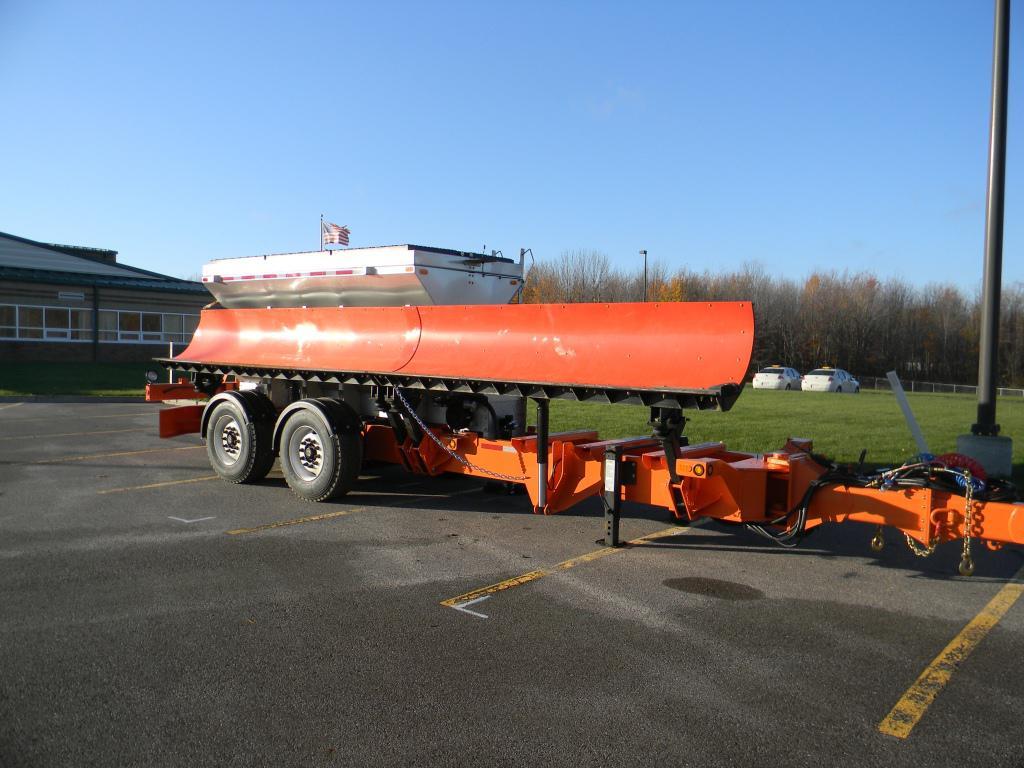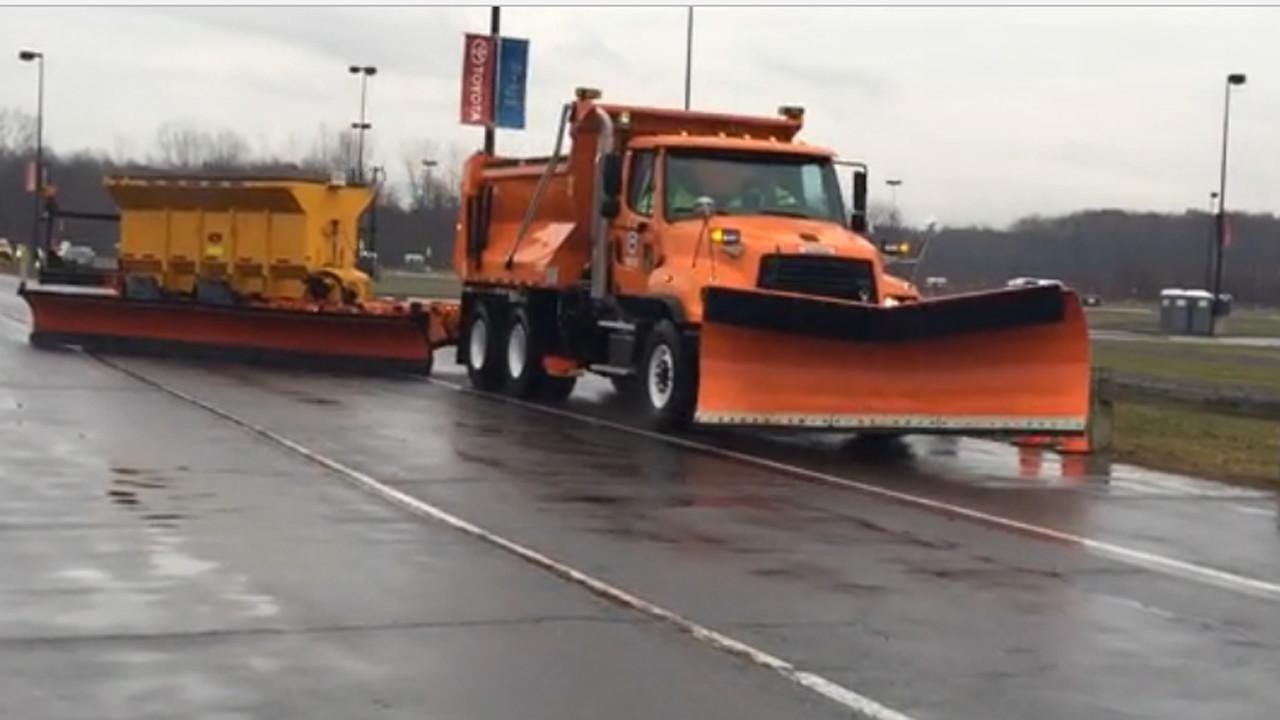The first image is the image on the left, the second image is the image on the right. Analyze the images presented: Is the assertion "An image shows a yellow-cabbed truck in front of a gray building, towing a trailer with a plow on the side." valid? Answer yes or no. No. The first image is the image on the left, the second image is the image on the right. Analyze the images presented: Is the assertion "The truck on the right has a plow, the truck on the left does not." valid? Answer yes or no. No. 